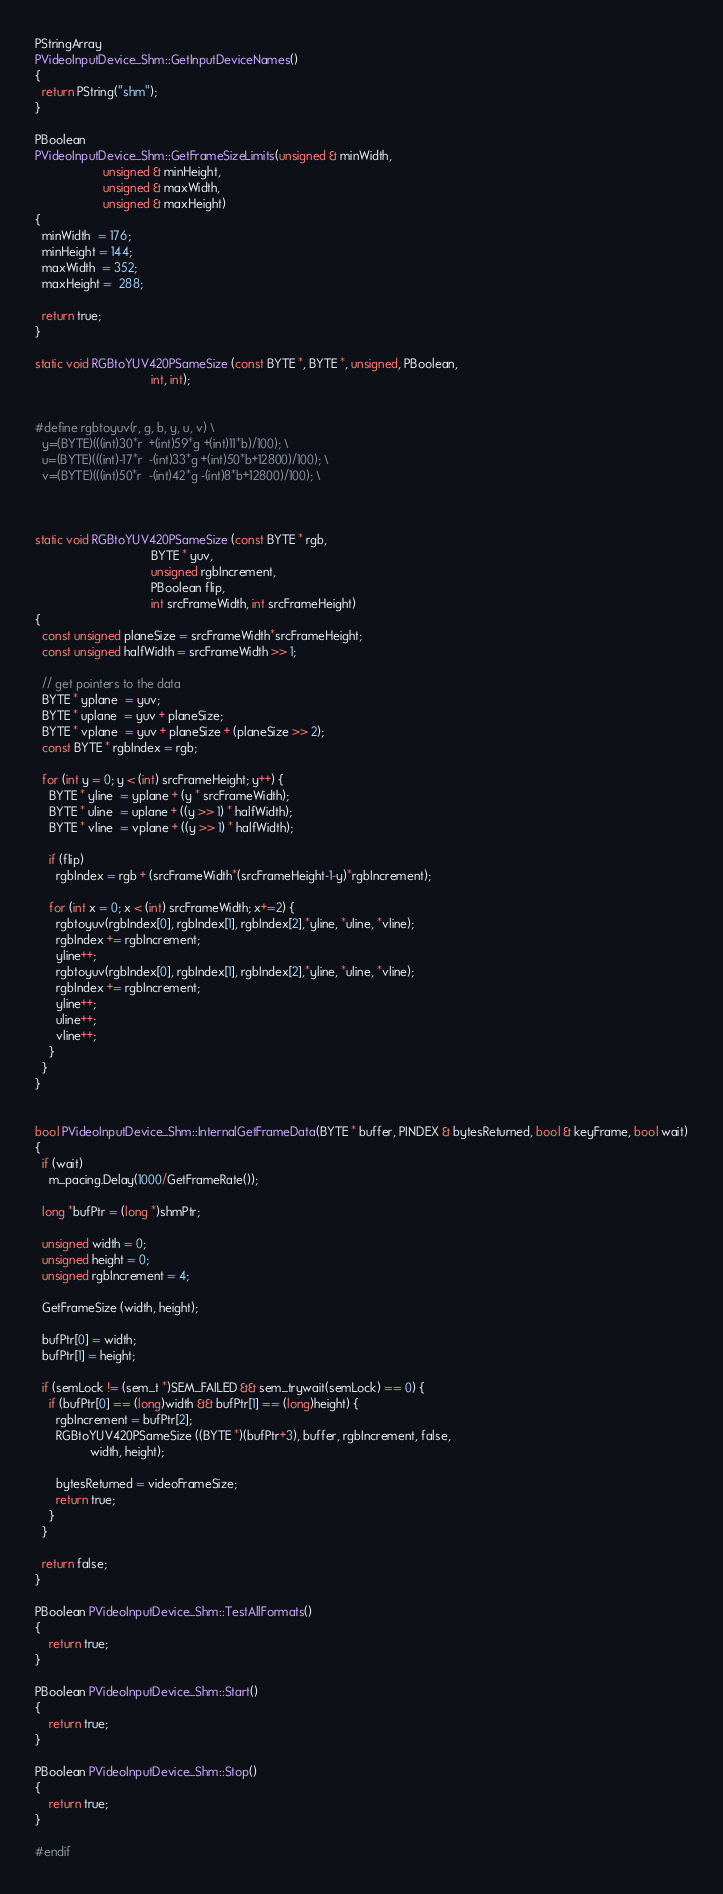Convert code to text. <code><loc_0><loc_0><loc_500><loc_500><_C++_>PStringArray
PVideoInputDevice_Shm::GetInputDeviceNames()
{
  return PString("shm");
}

PBoolean
PVideoInputDevice_Shm::GetFrameSizeLimits(unsigned & minWidth,
					unsigned & minHeight,
					unsigned & maxWidth,
					unsigned & maxHeight) 
{
  minWidth  = 176;
  minHeight = 144;
  maxWidth  = 352;
  maxHeight =  288;

  return true;
}

static void RGBtoYUV420PSameSize (const BYTE *, BYTE *, unsigned, PBoolean, 
                                  int, int);


#define rgbtoyuv(r, g, b, y, u, v) \
  y=(BYTE)(((int)30*r  +(int)59*g +(int)11*b)/100); \
  u=(BYTE)(((int)-17*r  -(int)33*g +(int)50*b+12800)/100); \
  v=(BYTE)(((int)50*r  -(int)42*g -(int)8*b+12800)/100); \



static void RGBtoYUV420PSameSize (const BYTE * rgb,
                                  BYTE * yuv,
                                  unsigned rgbIncrement,
                                  PBoolean flip, 
                                  int srcFrameWidth, int srcFrameHeight) 
{
  const unsigned planeSize = srcFrameWidth*srcFrameHeight;
  const unsigned halfWidth = srcFrameWidth >> 1;
  
  // get pointers to the data
  BYTE * yplane  = yuv;
  BYTE * uplane  = yuv + planeSize;
  BYTE * vplane  = yuv + planeSize + (planeSize >> 2);
  const BYTE * rgbIndex = rgb;

  for (int y = 0; y < (int) srcFrameHeight; y++) {
    BYTE * yline  = yplane + (y * srcFrameWidth);
    BYTE * uline  = uplane + ((y >> 1) * halfWidth);
    BYTE * vline  = vplane + ((y >> 1) * halfWidth);

    if (flip)
      rgbIndex = rgb + (srcFrameWidth*(srcFrameHeight-1-y)*rgbIncrement);

    for (int x = 0; x < (int) srcFrameWidth; x+=2) {
      rgbtoyuv(rgbIndex[0], rgbIndex[1], rgbIndex[2],*yline, *uline, *vline);
      rgbIndex += rgbIncrement;
      yline++;
      rgbtoyuv(rgbIndex[0], rgbIndex[1], rgbIndex[2],*yline, *uline, *vline);
      rgbIndex += rgbIncrement;
      yline++;
      uline++;
      vline++;
    }
  }
}


bool PVideoInputDevice_Shm::InternalGetFrameData(BYTE * buffer, PINDEX & bytesReturned, bool & keyFrame, bool wait)
{
  if (wait)
    m_pacing.Delay(1000/GetFrameRate());

  long *bufPtr = (long *)shmPtr;

  unsigned width = 0;
  unsigned height = 0;
  unsigned rgbIncrement = 4;

  GetFrameSize (width, height);

  bufPtr[0] = width;
  bufPtr[1] = height;

  if (semLock != (sem_t *)SEM_FAILED && sem_trywait(semLock) == 0) {
    if (bufPtr[0] == (long)width && bufPtr[1] == (long)height) {
      rgbIncrement = bufPtr[2];
      RGBtoYUV420PSameSize ((BYTE *)(bufPtr+3), buffer, rgbIncrement, false, 
			    width, height);
	  
	  bytesReturned = videoFrameSize;
      return true;
    }
  }

  return false;
}

PBoolean PVideoInputDevice_Shm::TestAllFormats()
{
	return true;
}

PBoolean PVideoInputDevice_Shm::Start()
{
	return true;
}

PBoolean PVideoInputDevice_Shm::Stop()
{
	return true;
}

#endif
</code> 